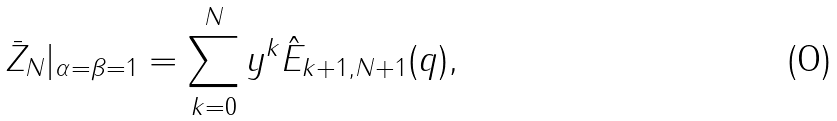Convert formula to latex. <formula><loc_0><loc_0><loc_500><loc_500>\bar { Z } _ { N } | _ { \alpha = \beta = 1 } = \sum _ { k = 0 } ^ { N } y ^ { k } \hat { E } _ { k + 1 , N + 1 } ( q ) ,</formula> 